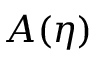Convert formula to latex. <formula><loc_0><loc_0><loc_500><loc_500>A ( { \eta } )</formula> 